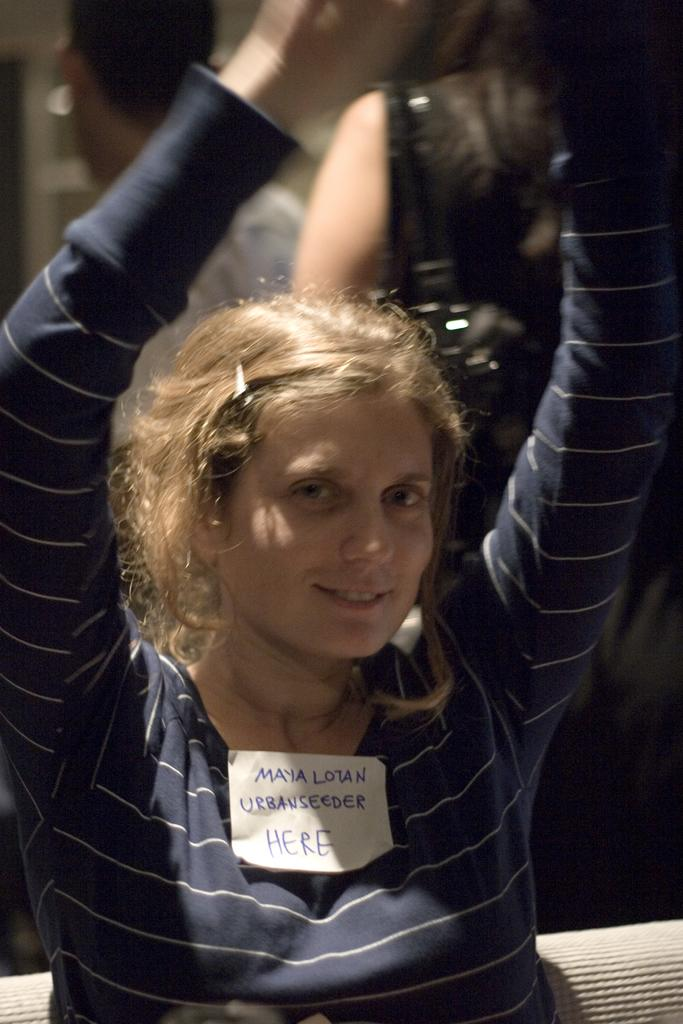What is the woman in the image doing? The woman is sitting in the image. What object is on the woman's shirt? There is a piece of paper on the woman's shirt. What type of jewel is hanging from the end of the string in the image? There is no string or jewel present in the image. 